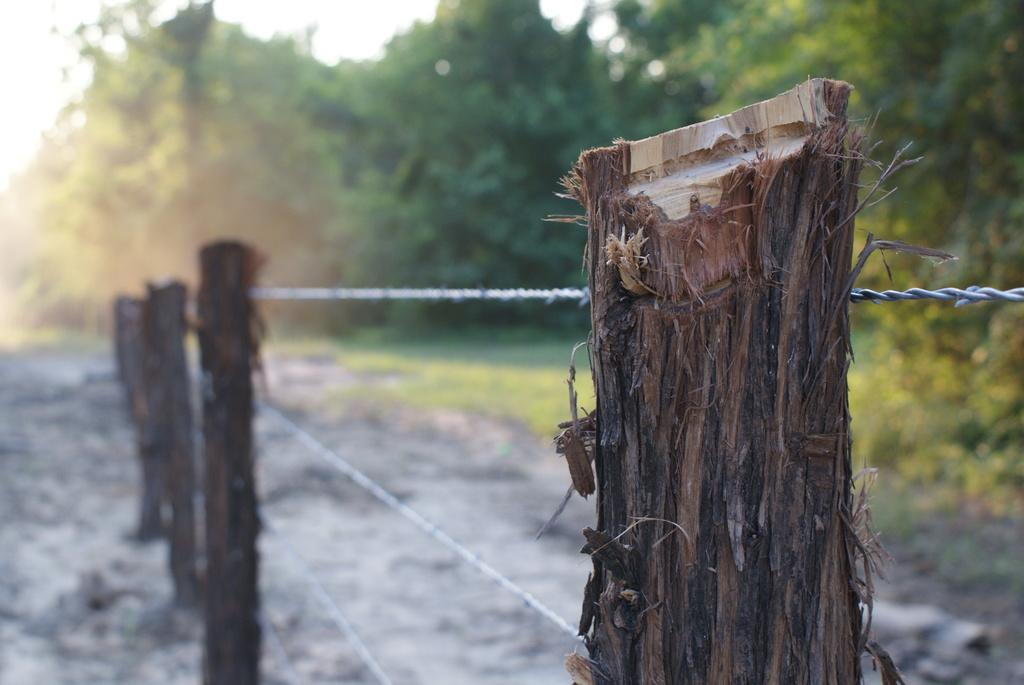What objects are on the ground in the image? There are wooden sticks visible on the ground. What can be seen at the top of the image? There is a fence and the sky visible at the top of the image. What type of natural elements are present in the image? There are trees visible in the image. What type of shoe is the representative wearing in the image? There is no representative or shoe present in the image. 